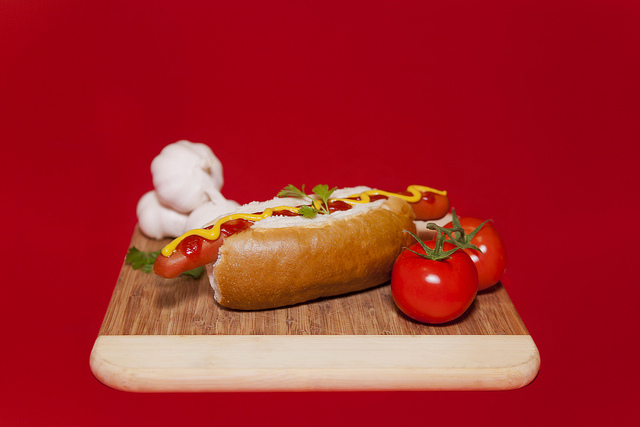What is the plate made of? The hot dog is placed on an intricately crafted wooden cutting board. 